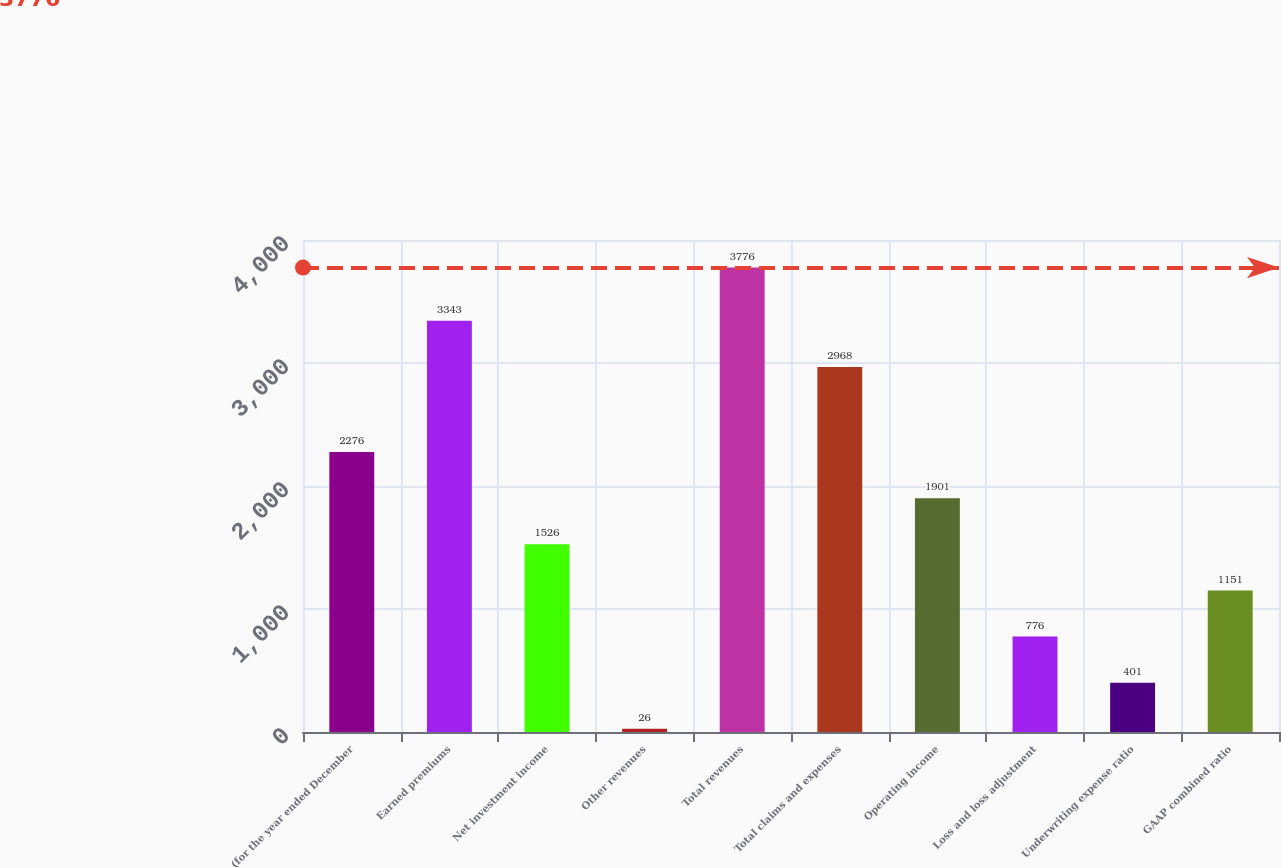<chart> <loc_0><loc_0><loc_500><loc_500><bar_chart><fcel>(for the year ended December<fcel>Earned premiums<fcel>Net investment income<fcel>Other revenues<fcel>Total revenues<fcel>Total claims and expenses<fcel>Operating income<fcel>Loss and loss adjustment<fcel>Underwriting expense ratio<fcel>GAAP combined ratio<nl><fcel>2276<fcel>3343<fcel>1526<fcel>26<fcel>3776<fcel>2968<fcel>1901<fcel>776<fcel>401<fcel>1151<nl></chart> 